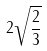Convert formula to latex. <formula><loc_0><loc_0><loc_500><loc_500>2 \sqrt { \frac { 2 } { 3 } }</formula> 